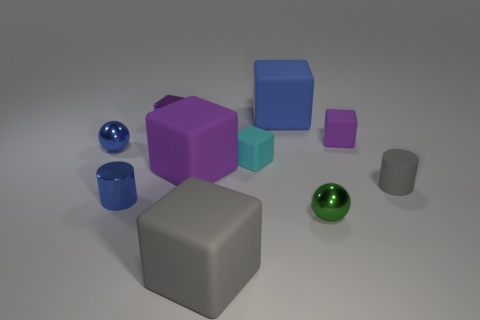Subtract all purple cubes. How many were subtracted if there are1purple cubes left? 2 Subtract all brown spheres. How many purple cubes are left? 3 Subtract all gray cubes. How many cubes are left? 5 Subtract all cyan blocks. How many blocks are left? 5 Subtract all brown blocks. Subtract all green balls. How many blocks are left? 6 Subtract all blocks. How many objects are left? 4 Add 3 matte spheres. How many matte spheres exist? 3 Subtract 0 red balls. How many objects are left? 10 Subtract all red metallic cylinders. Subtract all metal blocks. How many objects are left? 9 Add 6 metal cylinders. How many metal cylinders are left? 7 